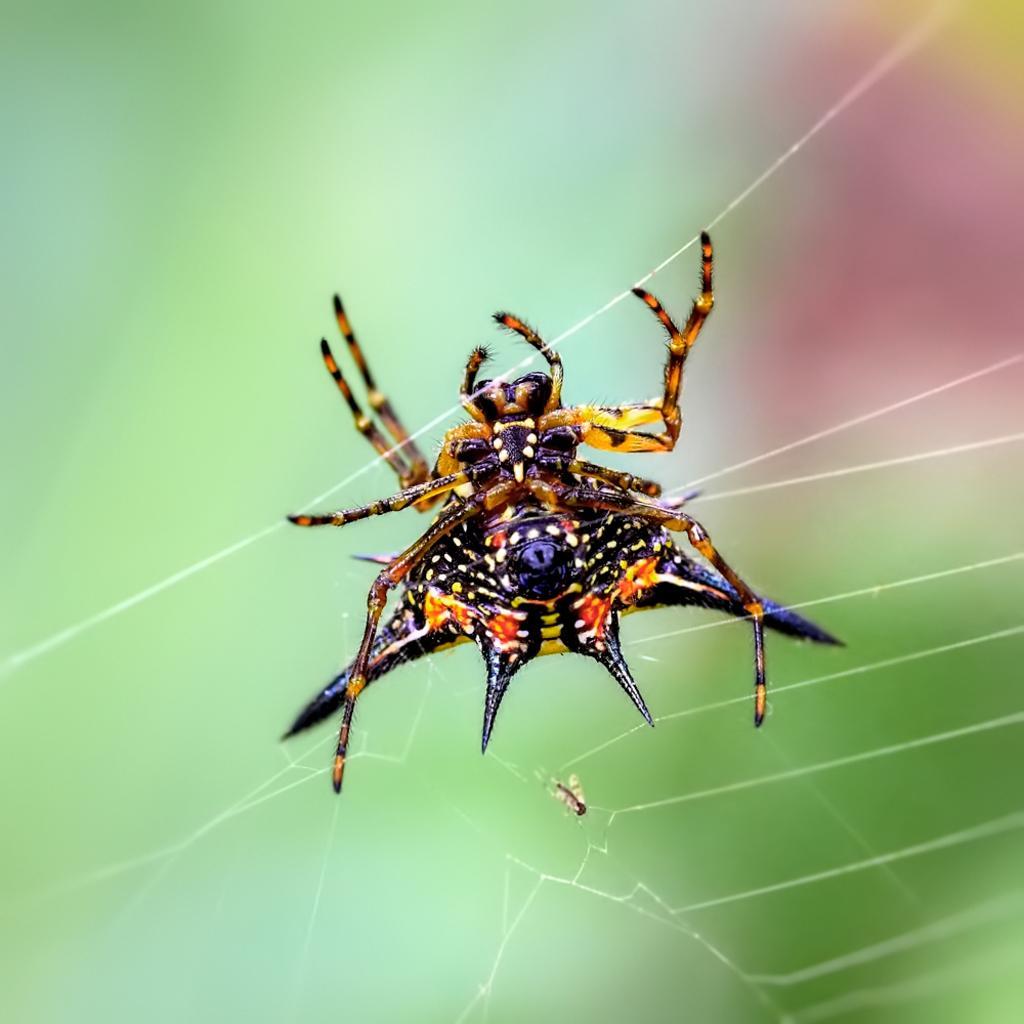Could you give a brief overview of what you see in this image? In the center of the image we can see spider in the web. 